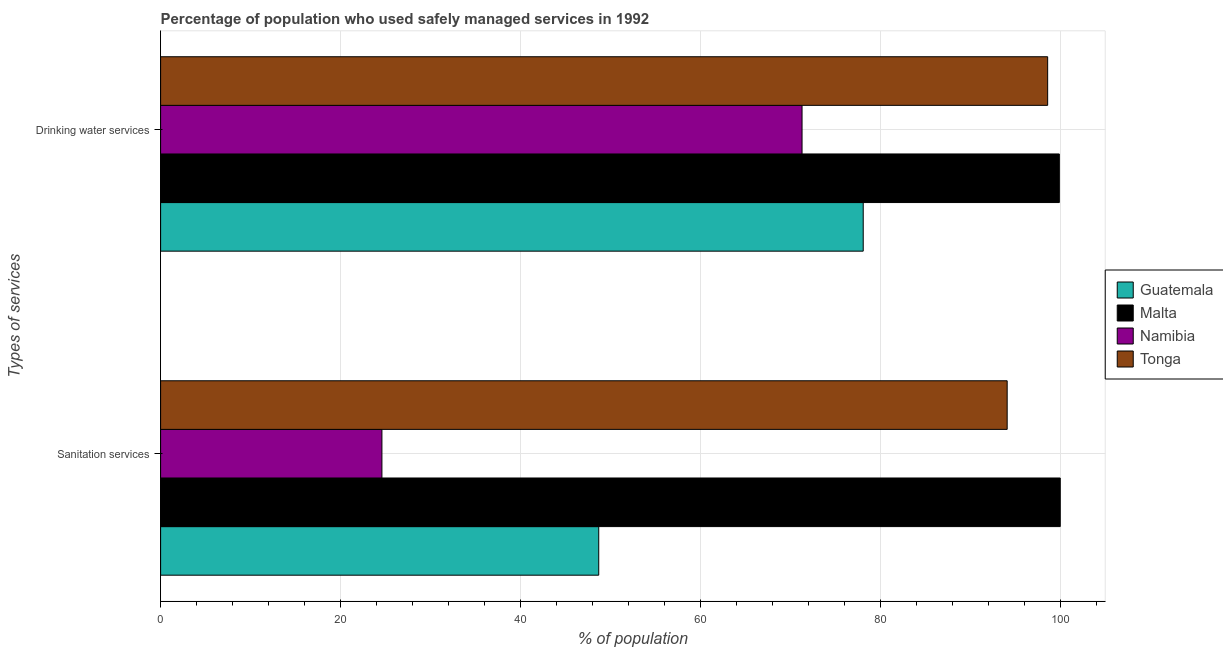How many different coloured bars are there?
Offer a terse response. 4. How many groups of bars are there?
Offer a terse response. 2. How many bars are there on the 2nd tick from the top?
Keep it short and to the point. 4. How many bars are there on the 1st tick from the bottom?
Your answer should be very brief. 4. What is the label of the 1st group of bars from the top?
Your response must be concise. Drinking water services. What is the percentage of population who used drinking water services in Guatemala?
Give a very brief answer. 78.1. Across all countries, what is the minimum percentage of population who used drinking water services?
Make the answer very short. 71.3. In which country was the percentage of population who used drinking water services maximum?
Ensure brevity in your answer.  Malta. In which country was the percentage of population who used sanitation services minimum?
Provide a succinct answer. Namibia. What is the total percentage of population who used drinking water services in the graph?
Your answer should be compact. 347.9. What is the difference between the percentage of population who used sanitation services in Malta and that in Guatemala?
Keep it short and to the point. 51.3. What is the difference between the percentage of population who used sanitation services in Malta and the percentage of population who used drinking water services in Namibia?
Provide a succinct answer. 28.7. What is the average percentage of population who used sanitation services per country?
Make the answer very short. 66.85. What is the difference between the percentage of population who used sanitation services and percentage of population who used drinking water services in Malta?
Make the answer very short. 0.1. In how many countries, is the percentage of population who used drinking water services greater than 20 %?
Your response must be concise. 4. What is the ratio of the percentage of population who used drinking water services in Malta to that in Tonga?
Your response must be concise. 1.01. In how many countries, is the percentage of population who used sanitation services greater than the average percentage of population who used sanitation services taken over all countries?
Your answer should be very brief. 2. What does the 3rd bar from the top in Sanitation services represents?
Your answer should be compact. Malta. What does the 2nd bar from the bottom in Drinking water services represents?
Provide a succinct answer. Malta. How many bars are there?
Ensure brevity in your answer.  8. Are all the bars in the graph horizontal?
Your response must be concise. Yes. Does the graph contain any zero values?
Offer a very short reply. No. How many legend labels are there?
Offer a terse response. 4. How are the legend labels stacked?
Provide a short and direct response. Vertical. What is the title of the graph?
Your response must be concise. Percentage of population who used safely managed services in 1992. What is the label or title of the X-axis?
Provide a short and direct response. % of population. What is the label or title of the Y-axis?
Offer a very short reply. Types of services. What is the % of population of Guatemala in Sanitation services?
Offer a terse response. 48.7. What is the % of population in Malta in Sanitation services?
Make the answer very short. 100. What is the % of population of Namibia in Sanitation services?
Make the answer very short. 24.6. What is the % of population in Tonga in Sanitation services?
Offer a very short reply. 94.1. What is the % of population in Guatemala in Drinking water services?
Provide a short and direct response. 78.1. What is the % of population in Malta in Drinking water services?
Ensure brevity in your answer.  99.9. What is the % of population of Namibia in Drinking water services?
Offer a terse response. 71.3. What is the % of population of Tonga in Drinking water services?
Ensure brevity in your answer.  98.6. Across all Types of services, what is the maximum % of population in Guatemala?
Give a very brief answer. 78.1. Across all Types of services, what is the maximum % of population in Namibia?
Offer a very short reply. 71.3. Across all Types of services, what is the maximum % of population of Tonga?
Ensure brevity in your answer.  98.6. Across all Types of services, what is the minimum % of population in Guatemala?
Your answer should be compact. 48.7. Across all Types of services, what is the minimum % of population in Malta?
Make the answer very short. 99.9. Across all Types of services, what is the minimum % of population in Namibia?
Offer a terse response. 24.6. Across all Types of services, what is the minimum % of population of Tonga?
Offer a terse response. 94.1. What is the total % of population in Guatemala in the graph?
Offer a very short reply. 126.8. What is the total % of population in Malta in the graph?
Give a very brief answer. 199.9. What is the total % of population in Namibia in the graph?
Your response must be concise. 95.9. What is the total % of population in Tonga in the graph?
Offer a terse response. 192.7. What is the difference between the % of population in Guatemala in Sanitation services and that in Drinking water services?
Make the answer very short. -29.4. What is the difference between the % of population in Namibia in Sanitation services and that in Drinking water services?
Offer a very short reply. -46.7. What is the difference between the % of population in Guatemala in Sanitation services and the % of population in Malta in Drinking water services?
Make the answer very short. -51.2. What is the difference between the % of population of Guatemala in Sanitation services and the % of population of Namibia in Drinking water services?
Make the answer very short. -22.6. What is the difference between the % of population of Guatemala in Sanitation services and the % of population of Tonga in Drinking water services?
Provide a succinct answer. -49.9. What is the difference between the % of population of Malta in Sanitation services and the % of population of Namibia in Drinking water services?
Make the answer very short. 28.7. What is the difference between the % of population of Namibia in Sanitation services and the % of population of Tonga in Drinking water services?
Provide a short and direct response. -74. What is the average % of population of Guatemala per Types of services?
Your response must be concise. 63.4. What is the average % of population in Malta per Types of services?
Make the answer very short. 99.95. What is the average % of population in Namibia per Types of services?
Offer a very short reply. 47.95. What is the average % of population in Tonga per Types of services?
Give a very brief answer. 96.35. What is the difference between the % of population of Guatemala and % of population of Malta in Sanitation services?
Offer a very short reply. -51.3. What is the difference between the % of population in Guatemala and % of population in Namibia in Sanitation services?
Your answer should be very brief. 24.1. What is the difference between the % of population in Guatemala and % of population in Tonga in Sanitation services?
Provide a succinct answer. -45.4. What is the difference between the % of population in Malta and % of population in Namibia in Sanitation services?
Ensure brevity in your answer.  75.4. What is the difference between the % of population in Namibia and % of population in Tonga in Sanitation services?
Your answer should be very brief. -69.5. What is the difference between the % of population of Guatemala and % of population of Malta in Drinking water services?
Your answer should be very brief. -21.8. What is the difference between the % of population of Guatemala and % of population of Tonga in Drinking water services?
Your answer should be very brief. -20.5. What is the difference between the % of population in Malta and % of population in Namibia in Drinking water services?
Your answer should be compact. 28.6. What is the difference between the % of population in Namibia and % of population in Tonga in Drinking water services?
Your response must be concise. -27.3. What is the ratio of the % of population in Guatemala in Sanitation services to that in Drinking water services?
Keep it short and to the point. 0.62. What is the ratio of the % of population in Malta in Sanitation services to that in Drinking water services?
Make the answer very short. 1. What is the ratio of the % of population in Namibia in Sanitation services to that in Drinking water services?
Your response must be concise. 0.34. What is the ratio of the % of population in Tonga in Sanitation services to that in Drinking water services?
Provide a short and direct response. 0.95. What is the difference between the highest and the second highest % of population of Guatemala?
Your response must be concise. 29.4. What is the difference between the highest and the second highest % of population in Namibia?
Your answer should be compact. 46.7. What is the difference between the highest and the second highest % of population in Tonga?
Ensure brevity in your answer.  4.5. What is the difference between the highest and the lowest % of population of Guatemala?
Offer a very short reply. 29.4. What is the difference between the highest and the lowest % of population of Malta?
Ensure brevity in your answer.  0.1. What is the difference between the highest and the lowest % of population in Namibia?
Keep it short and to the point. 46.7. 